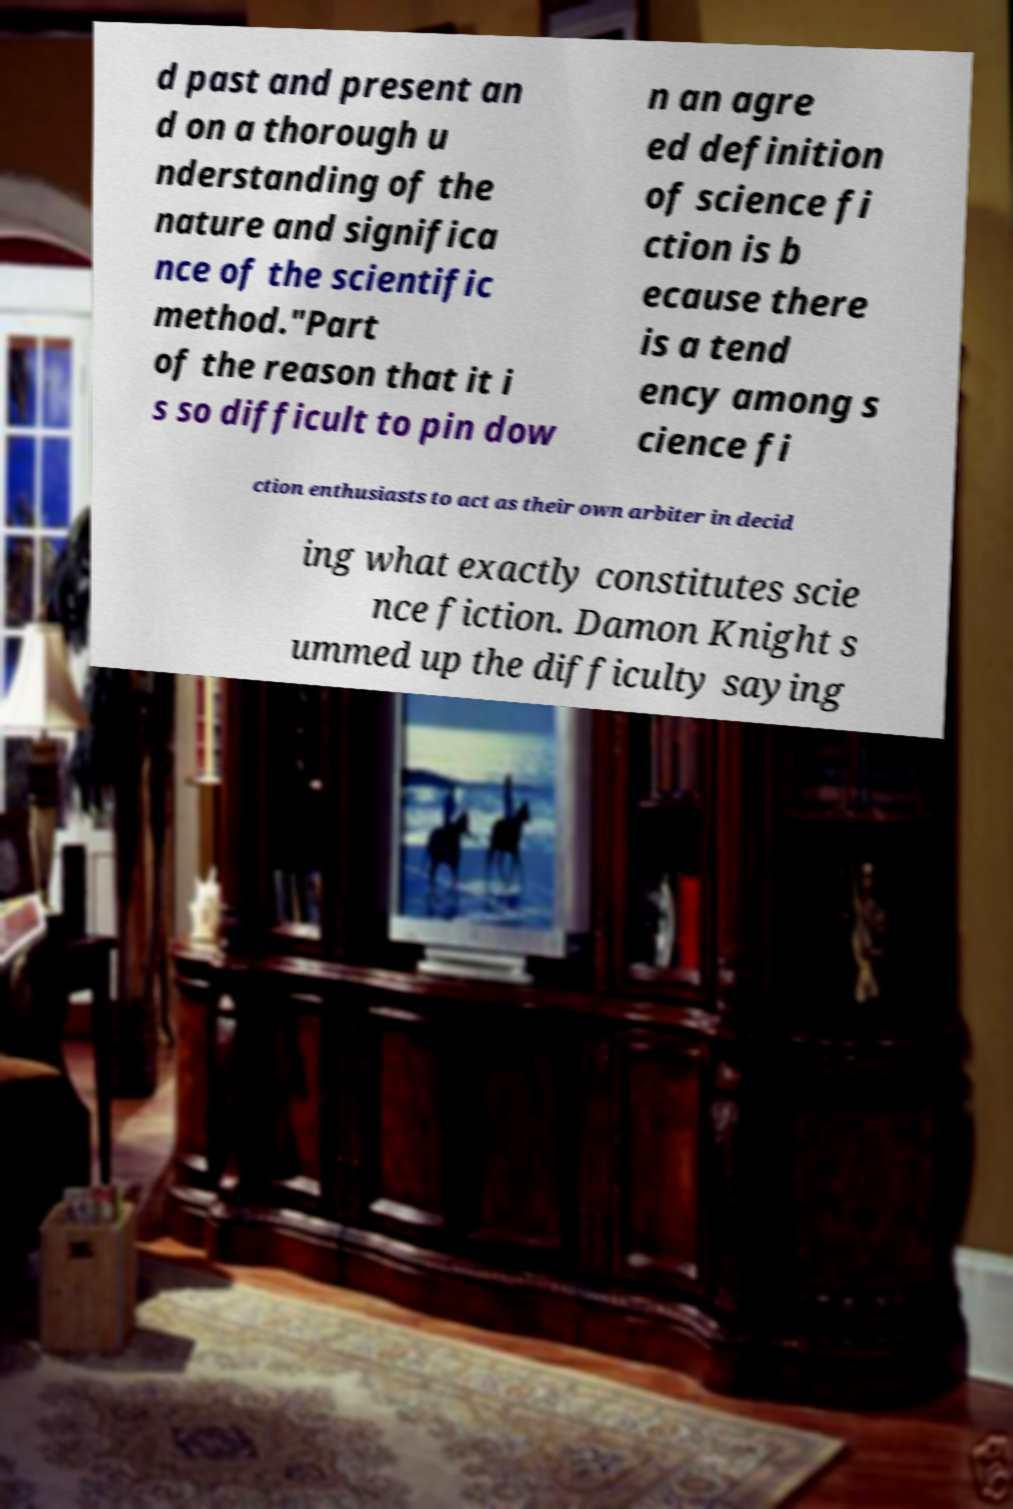Please identify and transcribe the text found in this image. d past and present an d on a thorough u nderstanding of the nature and significa nce of the scientific method."Part of the reason that it i s so difficult to pin dow n an agre ed definition of science fi ction is b ecause there is a tend ency among s cience fi ction enthusiasts to act as their own arbiter in decid ing what exactly constitutes scie nce fiction. Damon Knight s ummed up the difficulty saying 